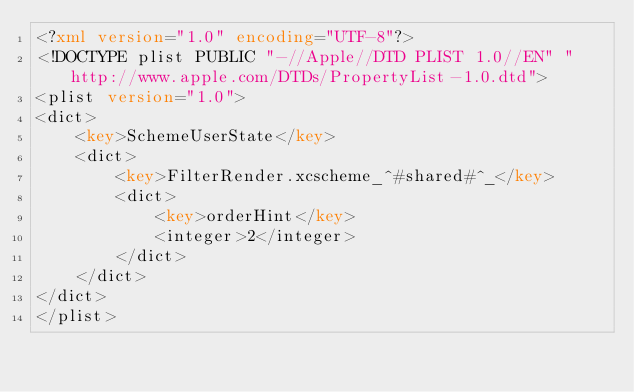<code> <loc_0><loc_0><loc_500><loc_500><_XML_><?xml version="1.0" encoding="UTF-8"?>
<!DOCTYPE plist PUBLIC "-//Apple//DTD PLIST 1.0//EN" "http://www.apple.com/DTDs/PropertyList-1.0.dtd">
<plist version="1.0">
<dict>
	<key>SchemeUserState</key>
	<dict>
		<key>FilterRender.xcscheme_^#shared#^_</key>
		<dict>
			<key>orderHint</key>
			<integer>2</integer>
		</dict>
	</dict>
</dict>
</plist>
</code> 